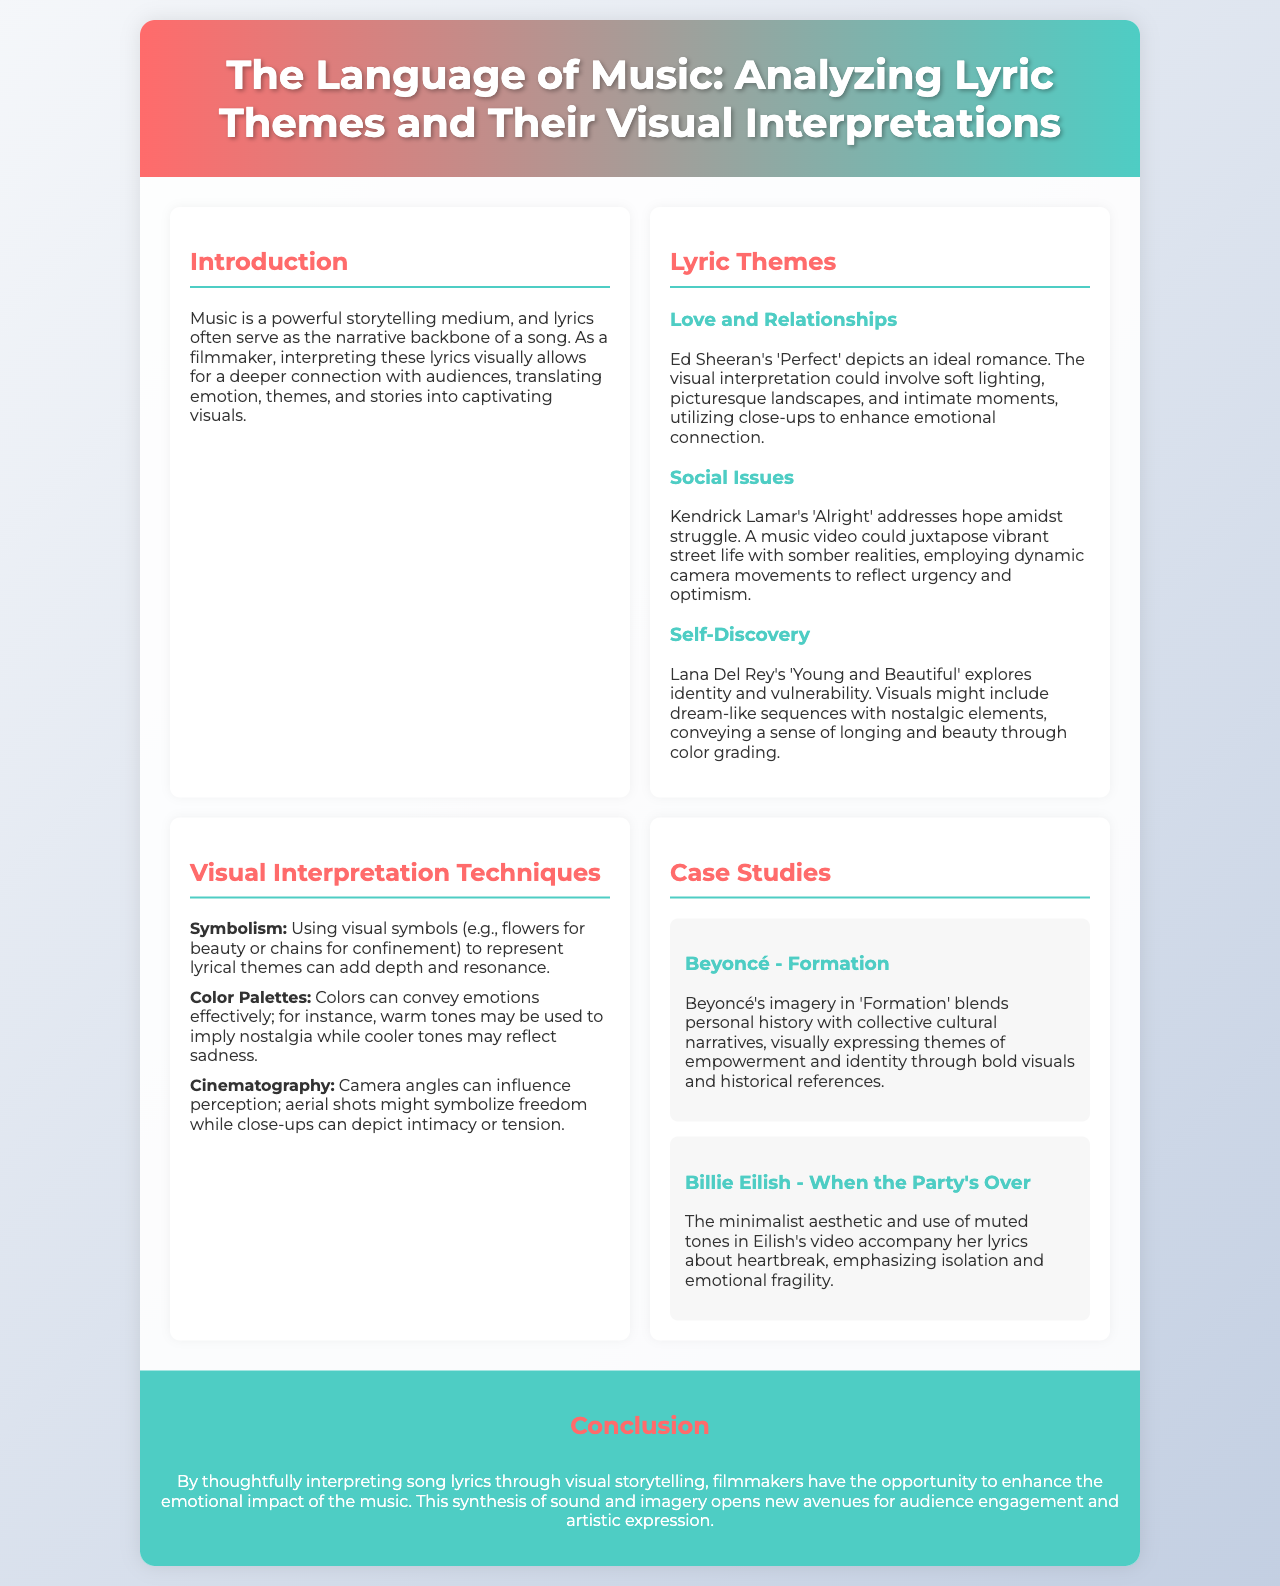What is the title of the brochure? The title of the brochure is presented in the header section, showcasing the main theme of the content.
Answer: The Language of Music: Analyzing Lyric Themes and Their Visual Interpretations Who is the artist associated with the song "Young and Beautiful"? The section discussing self-discovery specifically mentions this artist and their song.
Answer: Lana Del Rey What visual technique is mentioned for conveying emotions? The document lists various techniques, with one specifically emphasizing the use of visual symbols for thematic representation.
Answer: Symbolism Which song is analyzed under the case studies? The case studies section highlights specific songs, including one by this artist, reflecting on themes of empowerment.
Answer: Formation What color tones are suggested for implying nostalgia? The document mentions the emotional implications of color palettes and provides examples related to each.
Answer: Warm tones What theme is addressed in Kendrick Lamar's "Alright"? This theme is highlighted in the section discussing social issues, illustrating a significant part of the lyrical narrative.
Answer: Hope amidst struggle How does the brochure describe the role of filmmakers? It emphasizes the creative opportunity available to filmmakers when interpreting music visually, summarizing its impact on storytelling.
Answer: Enhance the emotional impact What is the main focus of the introduction? The introduction provides a foundational overview of how music and lyrics work together in storytelling, setting the stage for the rest of the brochure.
Answer: Music is a powerful storytelling medium 